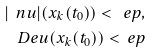Convert formula to latex. <formula><loc_0><loc_0><loc_500><loc_500>| \ n u | ( x _ { k } ( t _ { 0 } ) ) < \ e p , \\ \ D e u ( x _ { k } ( t _ { 0 } ) ) < \ e p</formula> 